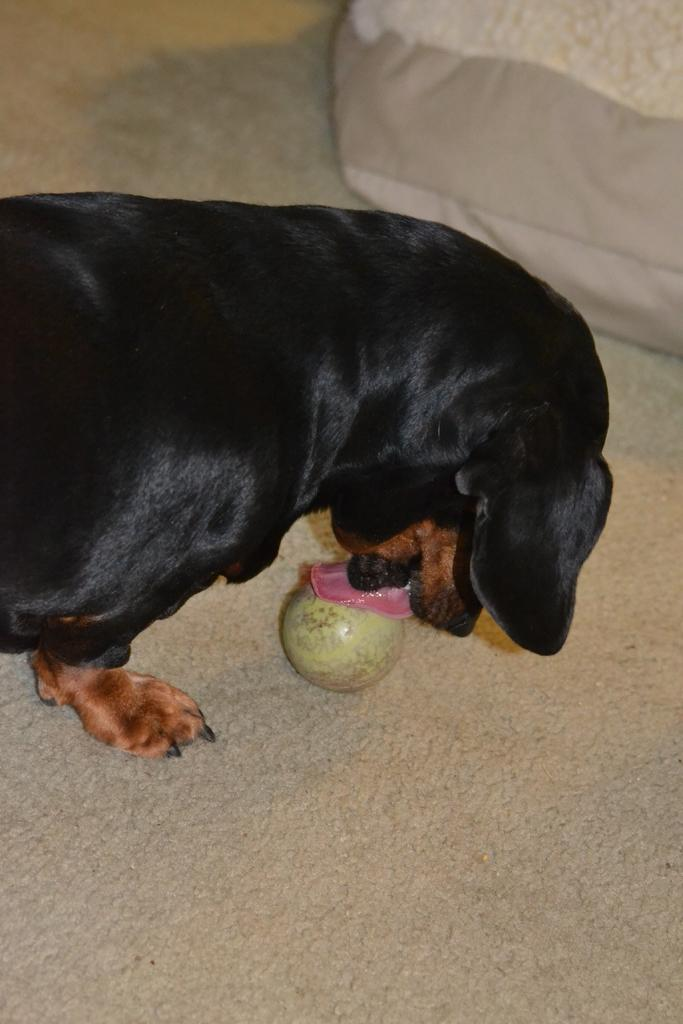What animal is present in the image? There is a dog in the image. What is the dog doing in the image? The dog is licking a round object. Can you describe the other object in the image? There is another object at the top of the image, but its description is not provided in the facts. How many sisters are present in the image? There are no sisters mentioned or depicted in the image. What type of flowers can be seen in the image? There is no mention of flowers in the image. 